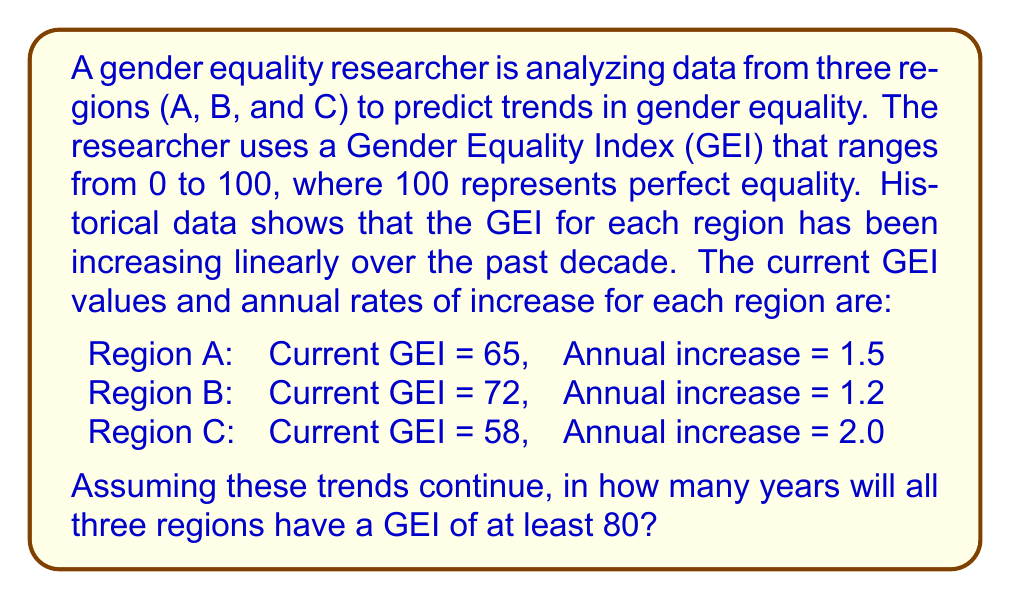Help me with this question. To solve this problem, we need to determine how long it will take for each region to reach a GEI of 80, and then find the maximum of these times. Let's approach this step-by-step:

1. For each region, we can use the linear equation:
   $$\text{GEI}_{\text{future}} = \text{GEI}_{\text{current}} + \text{Annual increase} \times \text{Years}$$

2. We want to find the number of years (t) when GEI_future = 80:
   $$80 = \text{GEI}_{\text{current}} + \text{Annual increase} \times t$$

3. Solving for t:
   $$t = \frac{80 - \text{GEI}_{\text{current}}}{\text{Annual increase}}$$

4. Now, let's calculate t for each region:

   Region A:
   $$t_A = \frac{80 - 65}{1.5} = 10 \text{ years}$$

   Region B:
   $$t_B = \frac{80 - 72}{1.2} = 6.67 \text{ years}$$

   Region C:
   $$t_C = \frac{80 - 58}{2.0} = 11 \text{ years}$$

5. The question asks for the time when all regions will have a GEI of at least 80. This means we need to find the maximum of these times:

   $$t_{max} = \max(t_A, t_B, t_C) = \max(10, 6.67, 11) = 11 \text{ years}$$

6. Since we're dealing with whole years, we need to round up to the nearest integer:
   $$\text{ceil}(11) = 11 \text{ years}$$

Therefore, it will take 11 years for all three regions to have a GEI of at least 80.
Answer: 11 years 